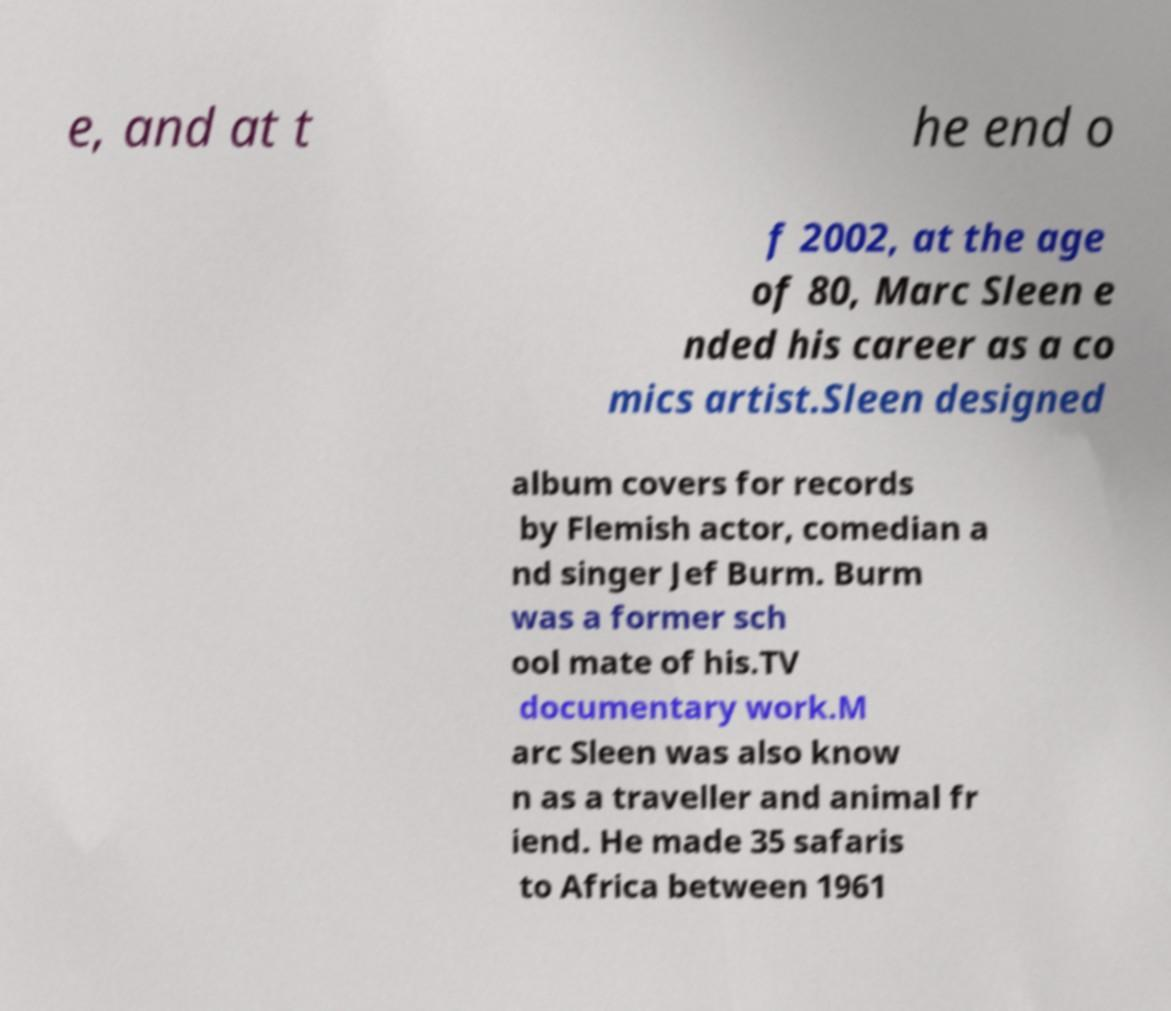For documentation purposes, I need the text within this image transcribed. Could you provide that? e, and at t he end o f 2002, at the age of 80, Marc Sleen e nded his career as a co mics artist.Sleen designed album covers for records by Flemish actor, comedian a nd singer Jef Burm. Burm was a former sch ool mate of his.TV documentary work.M arc Sleen was also know n as a traveller and animal fr iend. He made 35 safaris to Africa between 1961 